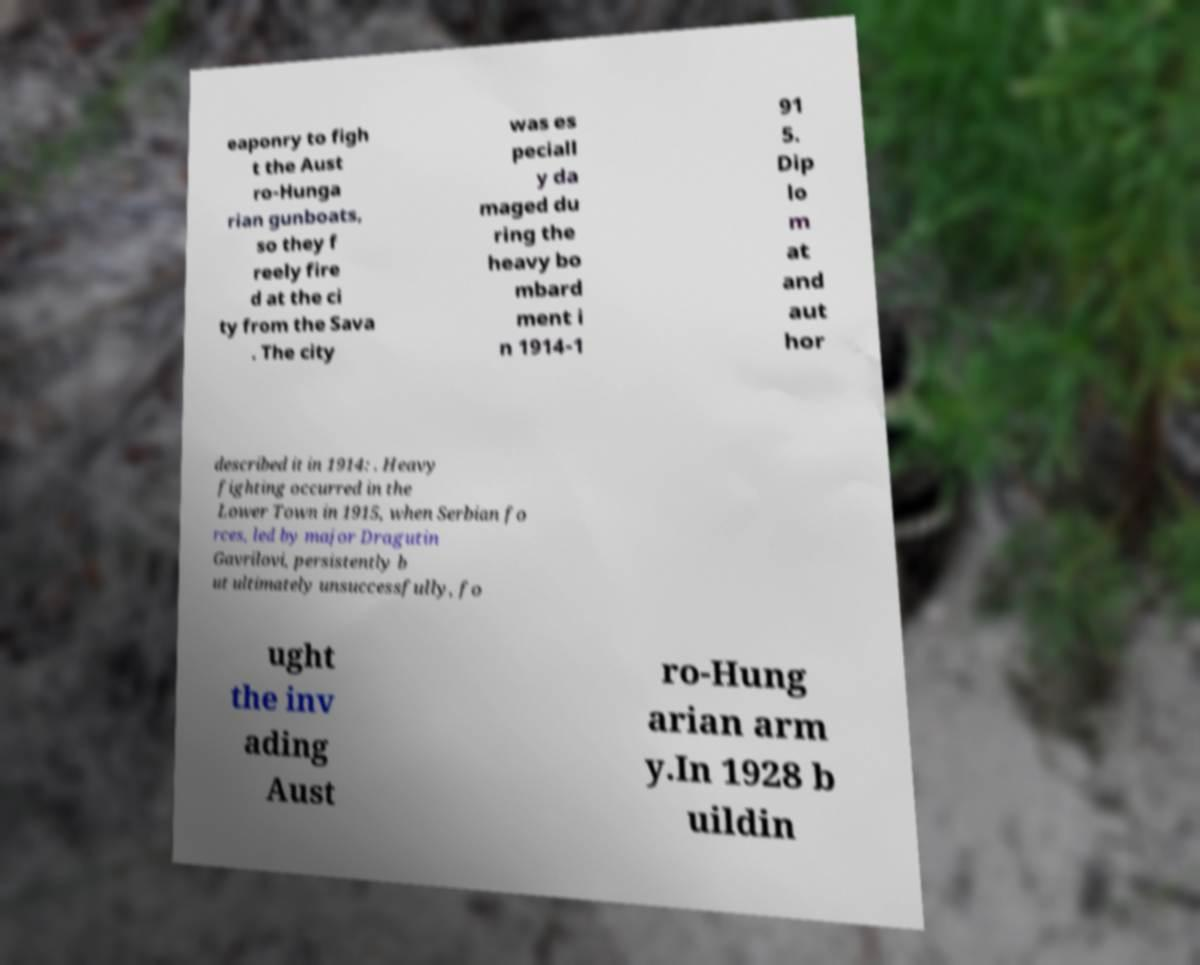Could you assist in decoding the text presented in this image and type it out clearly? eaponry to figh t the Aust ro-Hunga rian gunboats, so they f reely fire d at the ci ty from the Sava . The city was es peciall y da maged du ring the heavy bo mbard ment i n 1914-1 91 5. Dip lo m at and aut hor described it in 1914: . Heavy fighting occurred in the Lower Town in 1915, when Serbian fo rces, led by major Dragutin Gavrilovi, persistently b ut ultimately unsuccessfully, fo ught the inv ading Aust ro-Hung arian arm y.In 1928 b uildin 